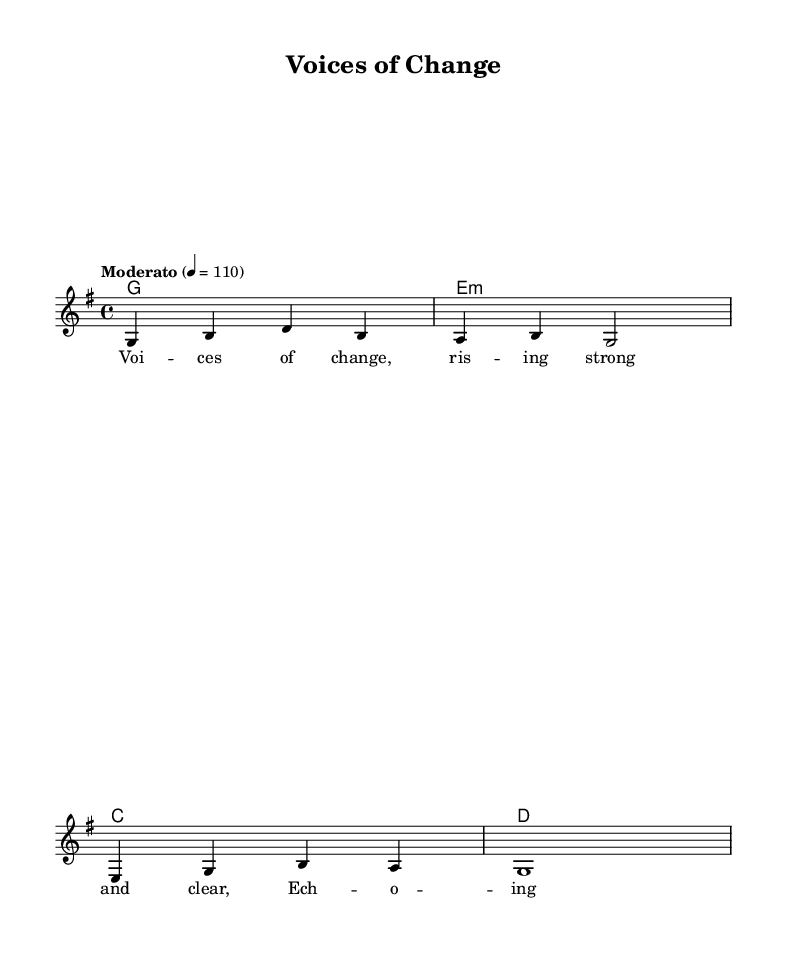What is the key signature of this music? The key signature is G major, which is indicated by one sharp (F#) on the staff.
Answer: G major What is the time signature of this music? The time signature is 4/4, which is shown at the beginning of the music and signifies four beats per measure.
Answer: 4/4 What is the tempo marked in the score? The tempo is marked as "Moderato," with a metronome marking of quarter note equals 110 beats per minute, indicating a moderate speed.
Answer: Moderato What is the first note of the melody? The first note of the melody is G, which is the lowest note at the beginning of the staff.
Answer: G How many measures does the piece contain? The piece consists of 4 measures, as counted by looking at the measure bars and the number of distinct grouping of notes.
Answer: 4 What is the form of the lyrics in the melody? The lyrics are structured as a couplet, with two lines that rhyme, emphasizing themes of hope and change, reflecting the folk-inspired sound.
Answer: Couplet Which type of harmony is used in the score? The harmony consists of simple triads (G, E minor, C, D), commonly found in folk music, supporting the melody throughout.
Answer: Triads 